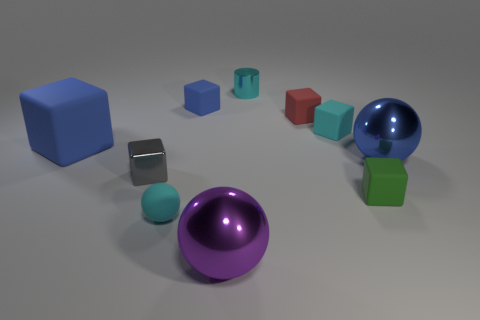Is the tiny cylinder the same color as the matte ball?
Give a very brief answer. Yes. There is a metallic thing behind the big blue matte cube; is its color the same as the rubber sphere?
Your answer should be very brief. Yes. How many matte spheres have the same color as the cylinder?
Your answer should be compact. 1. Is the number of matte objects that are left of the small cyan matte sphere greater than the number of blocks?
Give a very brief answer. No. The big purple metallic object has what shape?
Offer a very short reply. Sphere. There is a tiny cube that is left of the tiny blue rubber cube; is its color the same as the large ball that is in front of the big blue sphere?
Give a very brief answer. No. Do the red thing and the green thing have the same shape?
Offer a very short reply. Yes. Is there anything else that is the same shape as the tiny red object?
Provide a short and direct response. Yes. Does the cube behind the tiny red rubber block have the same material as the cylinder?
Ensure brevity in your answer.  No. There is a tiny cyan object that is both behind the small gray cube and in front of the small blue matte thing; what shape is it?
Offer a terse response. Cube. 